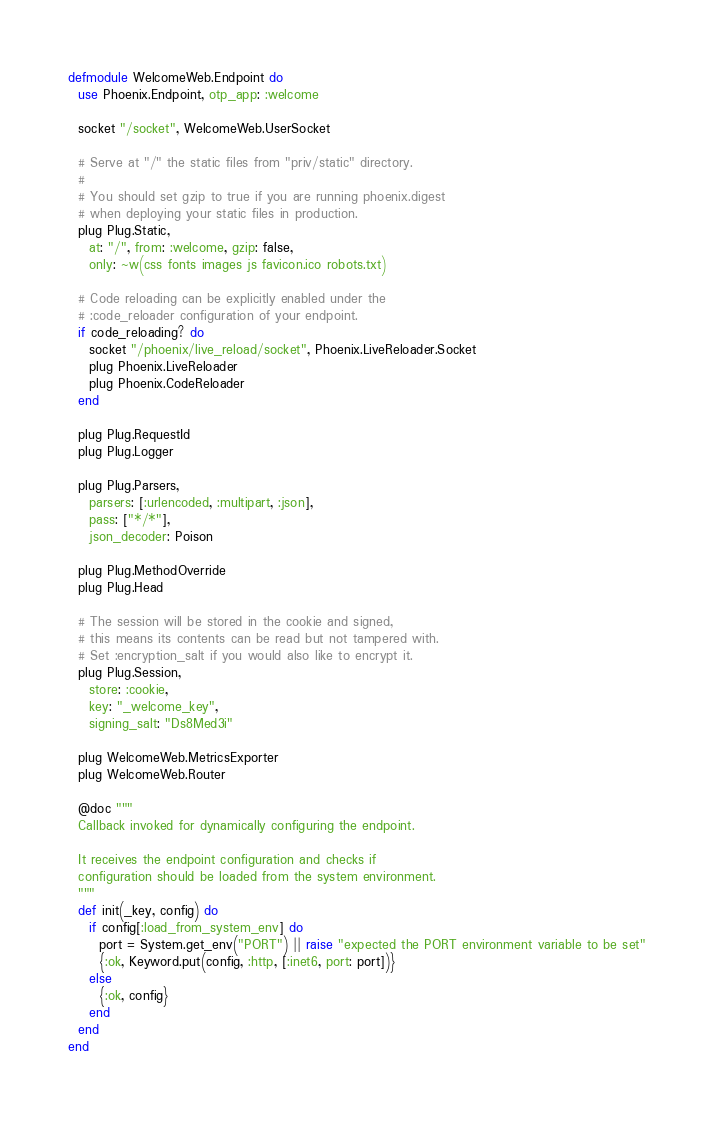Convert code to text. <code><loc_0><loc_0><loc_500><loc_500><_Elixir_>defmodule WelcomeWeb.Endpoint do
  use Phoenix.Endpoint, otp_app: :welcome

  socket "/socket", WelcomeWeb.UserSocket

  # Serve at "/" the static files from "priv/static" directory.
  #
  # You should set gzip to true if you are running phoenix.digest
  # when deploying your static files in production.
  plug Plug.Static,
    at: "/", from: :welcome, gzip: false,
    only: ~w(css fonts images js favicon.ico robots.txt)

  # Code reloading can be explicitly enabled under the
  # :code_reloader configuration of your endpoint.
  if code_reloading? do
    socket "/phoenix/live_reload/socket", Phoenix.LiveReloader.Socket
    plug Phoenix.LiveReloader
    plug Phoenix.CodeReloader
  end

  plug Plug.RequestId
  plug Plug.Logger

  plug Plug.Parsers,
    parsers: [:urlencoded, :multipart, :json],
    pass: ["*/*"],
    json_decoder: Poison

  plug Plug.MethodOverride
  plug Plug.Head

  # The session will be stored in the cookie and signed,
  # this means its contents can be read but not tampered with.
  # Set :encryption_salt if you would also like to encrypt it.
  plug Plug.Session,
    store: :cookie,
    key: "_welcome_key",
    signing_salt: "Ds8Med3i"

  plug WelcomeWeb.MetricsExporter
  plug WelcomeWeb.Router

  @doc """
  Callback invoked for dynamically configuring the endpoint.

  It receives the endpoint configuration and checks if
  configuration should be loaded from the system environment.
  """
  def init(_key, config) do
    if config[:load_from_system_env] do
      port = System.get_env("PORT") || raise "expected the PORT environment variable to be set"
      {:ok, Keyword.put(config, :http, [:inet6, port: port])}
    else
      {:ok, config}
    end
  end
end
</code> 